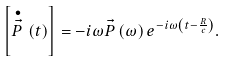Convert formula to latex. <formula><loc_0><loc_0><loc_500><loc_500>\left [ \stackrel { \bullet } { \vec { P } } \left ( t \right ) \right ] = - i \omega \vec { P } \left ( \omega \right ) e ^ { - i \omega \left ( t - \frac { R } { c } \right ) } .</formula> 